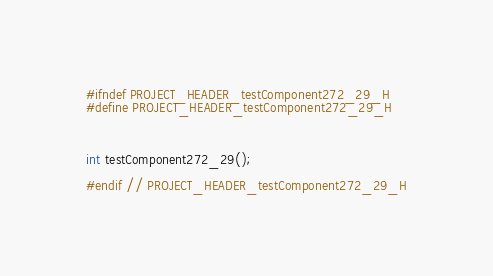Convert code to text. <code><loc_0><loc_0><loc_500><loc_500><_C_>#ifndef PROJECT_HEADER_testComponent272_29_H
#define PROJECT_HEADER_testComponent272_29_H



int testComponent272_29();

#endif // PROJECT_HEADER_testComponent272_29_H</code> 